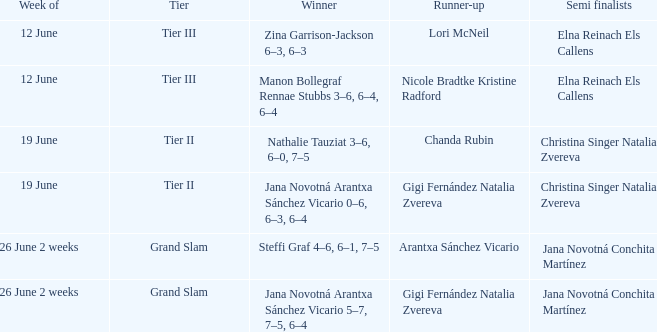During which week is jana novotná arantxa sánchez vicario declared the winner with the scores 5-7, 7-5, 6-4? 26 June 2 weeks. 